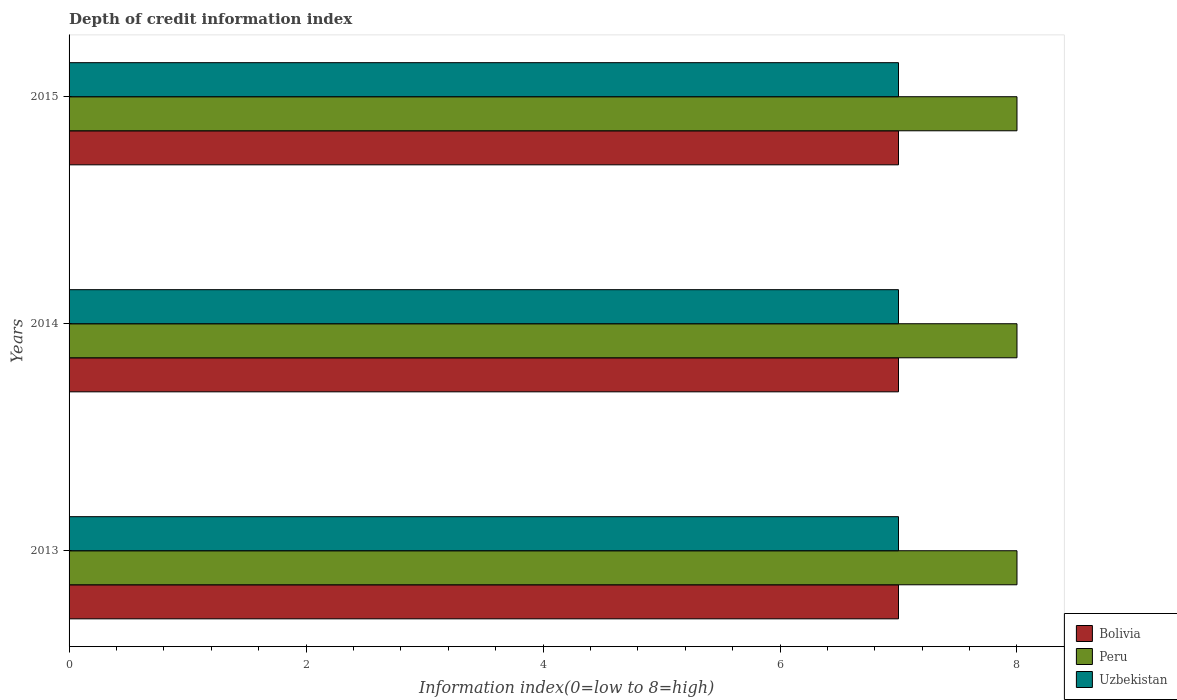Are the number of bars on each tick of the Y-axis equal?
Keep it short and to the point. Yes. How many bars are there on the 2nd tick from the top?
Your response must be concise. 3. How many bars are there on the 1st tick from the bottom?
Your response must be concise. 3. What is the label of the 1st group of bars from the top?
Make the answer very short. 2015. What is the information index in Peru in 2015?
Make the answer very short. 8. Across all years, what is the maximum information index in Uzbekistan?
Give a very brief answer. 7. Across all years, what is the minimum information index in Bolivia?
Ensure brevity in your answer.  7. In which year was the information index in Uzbekistan maximum?
Your answer should be compact. 2013. What is the total information index in Bolivia in the graph?
Your response must be concise. 21. What is the difference between the information index in Uzbekistan in 2014 and that in 2015?
Your answer should be very brief. 0. What is the difference between the information index in Peru in 2013 and the information index in Uzbekistan in 2015?
Your answer should be very brief. 1. What is the average information index in Bolivia per year?
Offer a very short reply. 7. In the year 2013, what is the difference between the information index in Peru and information index in Bolivia?
Your answer should be compact. 1. What is the ratio of the information index in Peru in 2013 to that in 2014?
Provide a short and direct response. 1. Is the difference between the information index in Peru in 2013 and 2014 greater than the difference between the information index in Bolivia in 2013 and 2014?
Provide a short and direct response. No. In how many years, is the information index in Bolivia greater than the average information index in Bolivia taken over all years?
Ensure brevity in your answer.  0. What does the 2nd bar from the top in 2015 represents?
Provide a succinct answer. Peru. Does the graph contain any zero values?
Provide a short and direct response. No. Where does the legend appear in the graph?
Give a very brief answer. Bottom right. How many legend labels are there?
Offer a terse response. 3. How are the legend labels stacked?
Provide a succinct answer. Vertical. What is the title of the graph?
Your answer should be very brief. Depth of credit information index. Does "San Marino" appear as one of the legend labels in the graph?
Your answer should be compact. No. What is the label or title of the X-axis?
Ensure brevity in your answer.  Information index(0=low to 8=high). What is the Information index(0=low to 8=high) in Peru in 2013?
Offer a very short reply. 8. What is the Information index(0=low to 8=high) of Bolivia in 2014?
Provide a short and direct response. 7. What is the Information index(0=low to 8=high) of Uzbekistan in 2014?
Keep it short and to the point. 7. What is the Information index(0=low to 8=high) in Bolivia in 2015?
Keep it short and to the point. 7. Across all years, what is the maximum Information index(0=low to 8=high) in Bolivia?
Give a very brief answer. 7. Across all years, what is the maximum Information index(0=low to 8=high) in Peru?
Your answer should be compact. 8. Across all years, what is the minimum Information index(0=low to 8=high) of Bolivia?
Offer a very short reply. 7. Across all years, what is the minimum Information index(0=low to 8=high) in Uzbekistan?
Keep it short and to the point. 7. What is the total Information index(0=low to 8=high) in Bolivia in the graph?
Provide a succinct answer. 21. What is the difference between the Information index(0=low to 8=high) in Peru in 2013 and that in 2014?
Your response must be concise. 0. What is the difference between the Information index(0=low to 8=high) of Uzbekistan in 2013 and that in 2014?
Offer a very short reply. 0. What is the difference between the Information index(0=low to 8=high) of Peru in 2013 and the Information index(0=low to 8=high) of Uzbekistan in 2014?
Offer a terse response. 1. What is the difference between the Information index(0=low to 8=high) in Bolivia in 2013 and the Information index(0=low to 8=high) in Uzbekistan in 2015?
Ensure brevity in your answer.  0. What is the difference between the Information index(0=low to 8=high) in Peru in 2013 and the Information index(0=low to 8=high) in Uzbekistan in 2015?
Make the answer very short. 1. What is the difference between the Information index(0=low to 8=high) of Bolivia in 2014 and the Information index(0=low to 8=high) of Peru in 2015?
Keep it short and to the point. -1. What is the average Information index(0=low to 8=high) in Uzbekistan per year?
Offer a very short reply. 7. In the year 2013, what is the difference between the Information index(0=low to 8=high) of Peru and Information index(0=low to 8=high) of Uzbekistan?
Your answer should be compact. 1. In the year 2014, what is the difference between the Information index(0=low to 8=high) of Bolivia and Information index(0=low to 8=high) of Peru?
Provide a succinct answer. -1. In the year 2014, what is the difference between the Information index(0=low to 8=high) in Bolivia and Information index(0=low to 8=high) in Uzbekistan?
Your response must be concise. 0. In the year 2014, what is the difference between the Information index(0=low to 8=high) in Peru and Information index(0=low to 8=high) in Uzbekistan?
Your answer should be compact. 1. What is the ratio of the Information index(0=low to 8=high) in Bolivia in 2013 to that in 2014?
Make the answer very short. 1. What is the ratio of the Information index(0=low to 8=high) in Peru in 2013 to that in 2014?
Your answer should be very brief. 1. What is the ratio of the Information index(0=low to 8=high) of Peru in 2013 to that in 2015?
Provide a succinct answer. 1. What is the ratio of the Information index(0=low to 8=high) in Bolivia in 2014 to that in 2015?
Your response must be concise. 1. What is the ratio of the Information index(0=low to 8=high) of Uzbekistan in 2014 to that in 2015?
Provide a succinct answer. 1. What is the difference between the highest and the lowest Information index(0=low to 8=high) of Peru?
Provide a short and direct response. 0. 